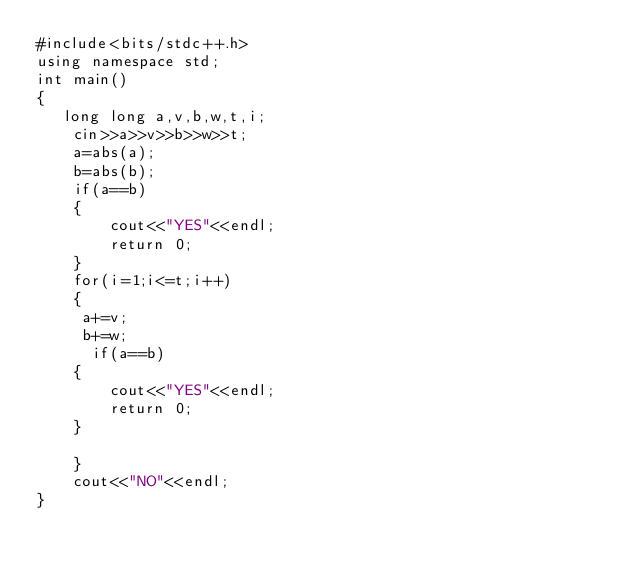<code> <loc_0><loc_0><loc_500><loc_500><_C++_>#include<bits/stdc++.h>
using namespace std;
int main()
{
   long long a,v,b,w,t,i;
    cin>>a>>v>>b>>w>>t;
    a=abs(a);
    b=abs(b);
    if(a==b)
    {
        cout<<"YES"<<endl;
        return 0;
    }
    for(i=1;i<=t;i++)
    {
     a+=v;
     b+=w;
      if(a==b)
    {
        cout<<"YES"<<endl;
        return 0;
    }

    }
    cout<<"NO"<<endl;
}</code> 